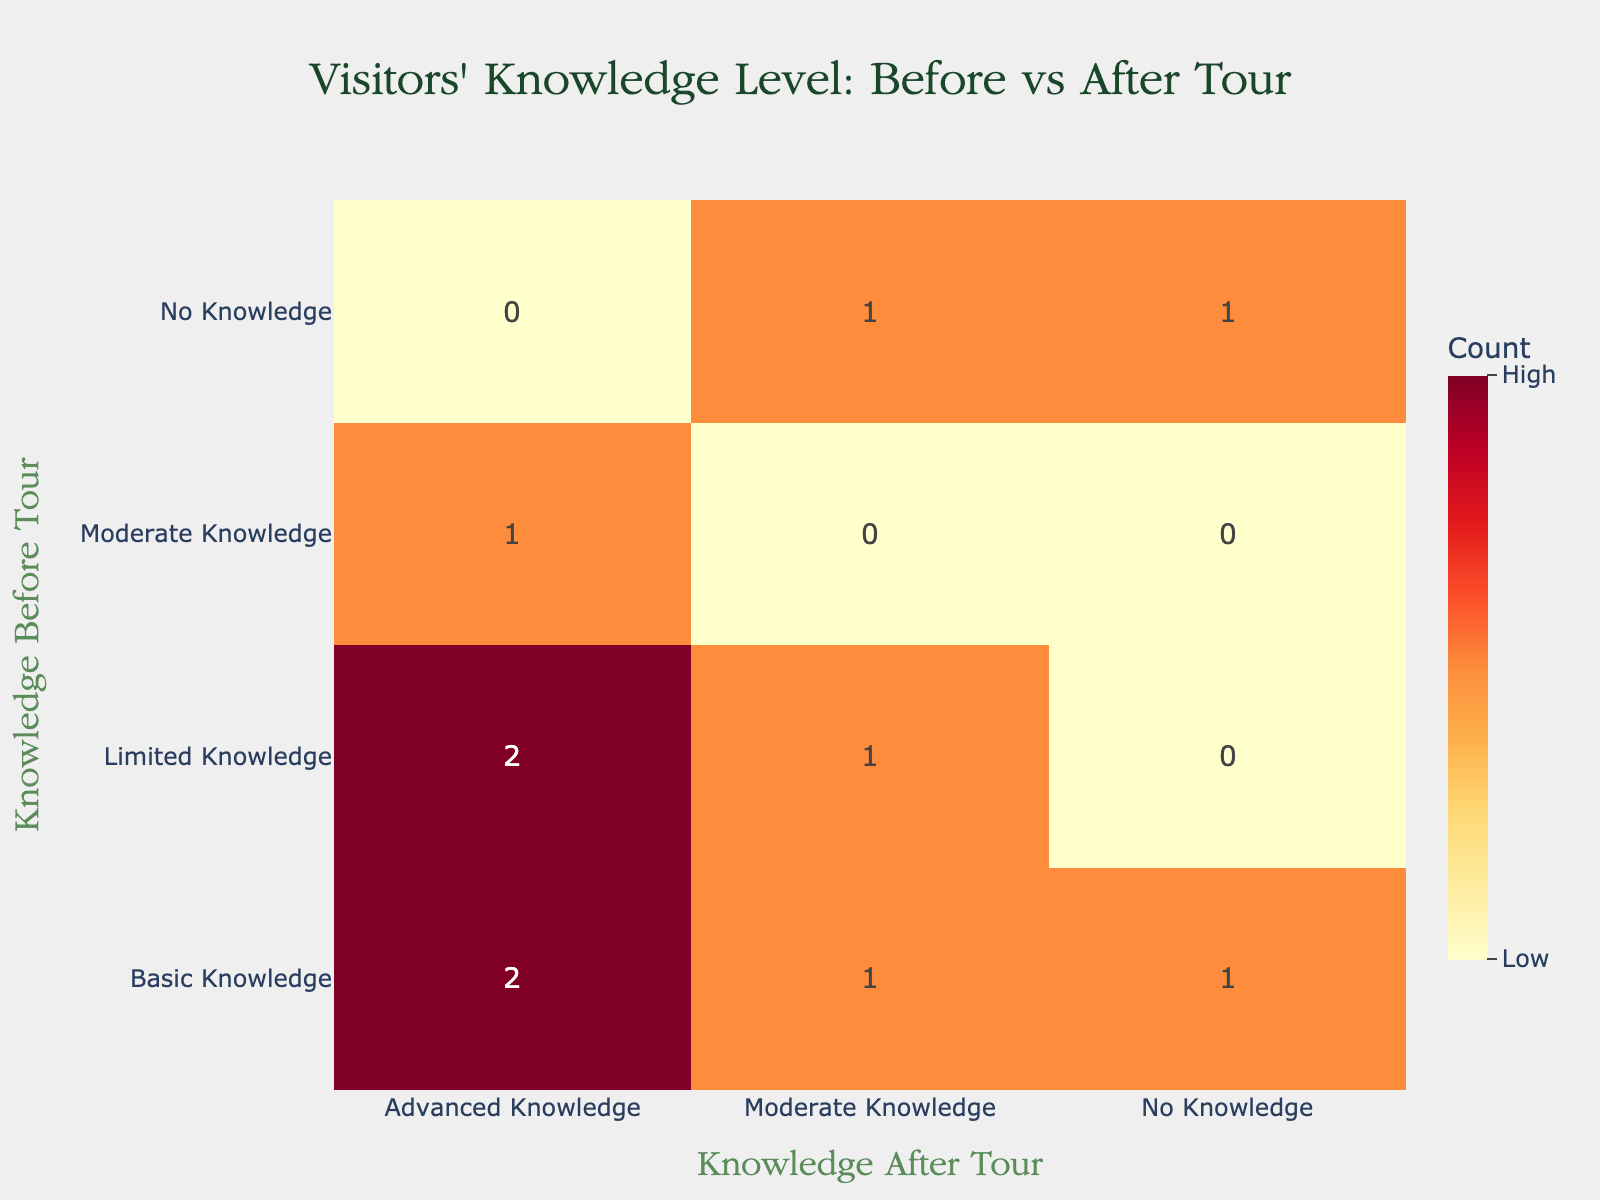What is the total number of visitors who had "Basic Knowledge" before the tour and ended up with "Advanced Knowledge" after the tour? There are two records in the table where visitors had "Basic Knowledge" before and "Advanced Knowledge" after. This is indicated by the entries showing "Basic Knowledge" leading to "Advanced Knowledge" with a count of 1 for each. Therefore, the total is 1 + 1 = 2.
Answer: 2 How many visitors had "No Knowledge" before the tour and did not improve their knowledge after the tour? There is one entry where "No Knowledge" before the tour leads to "No Knowledge" after the tour. The count for this combination shows a total of 1 visitor who did not improve their knowledge.
Answer: 1 What is the percentage of visitors who improved their knowledge level after the tour compared to the total number of visitors? By counting the total visitors who improved their knowledge, which are in the "Effective" category, we have 5 (1+1+1+1+1), and the total number of records is 10. The percentage of improvement is (5 / 10) * 100 = 50%.
Answer: 50% Is it true that all visitors with "Limited Knowledge" before the tour improved to "Advanced Knowledge"? Looking at the table, there are two cases for "Limited Knowledge" before the tour. One visitor moved to "Moderate Knowledge" and one to "Advanced Knowledge." Hence, it is not true that all visitors with "Limited Knowledge" improved to "Advanced Knowledge."
Answer: No What is the difference in the number of visitors who went from "No Knowledge" to "Moderate Knowledge" versus those who went from "Limited Knowledge" to "Advanced Knowledge"? The entry showing "No Knowledge" to "Moderate Knowledge" has a count of 1 visitor. For "Limited Knowledge" to "Advanced Knowledge," there is a count of 1, but there is also a case of 0 where a visitor did not improve. So, the difference is 1 - 1 = 0.
Answer: 0 